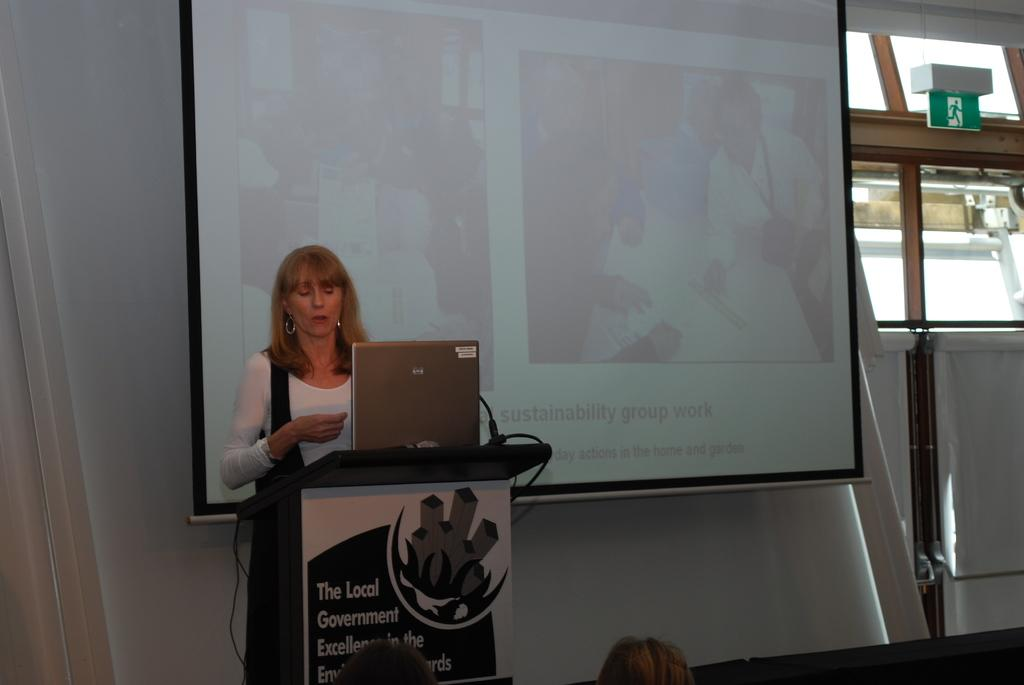What is placed on the podium in the image? There is a laptop on the podium. Can you describe the background of the image? There is a lady, a screen, windows, and other people in the background. How many people are visible in the image? There are at least two people visible in the image: the lady in the background and the people at the bottom of the image. What might be the purpose of the screen in the background? The screen in the background might be used for displaying information or visuals during a presentation or event. What type of pancake is being served to the doctor in the image? There is no pancake or doctor present in the image. What material is the copper used for in the image? There is no copper present in the image. 